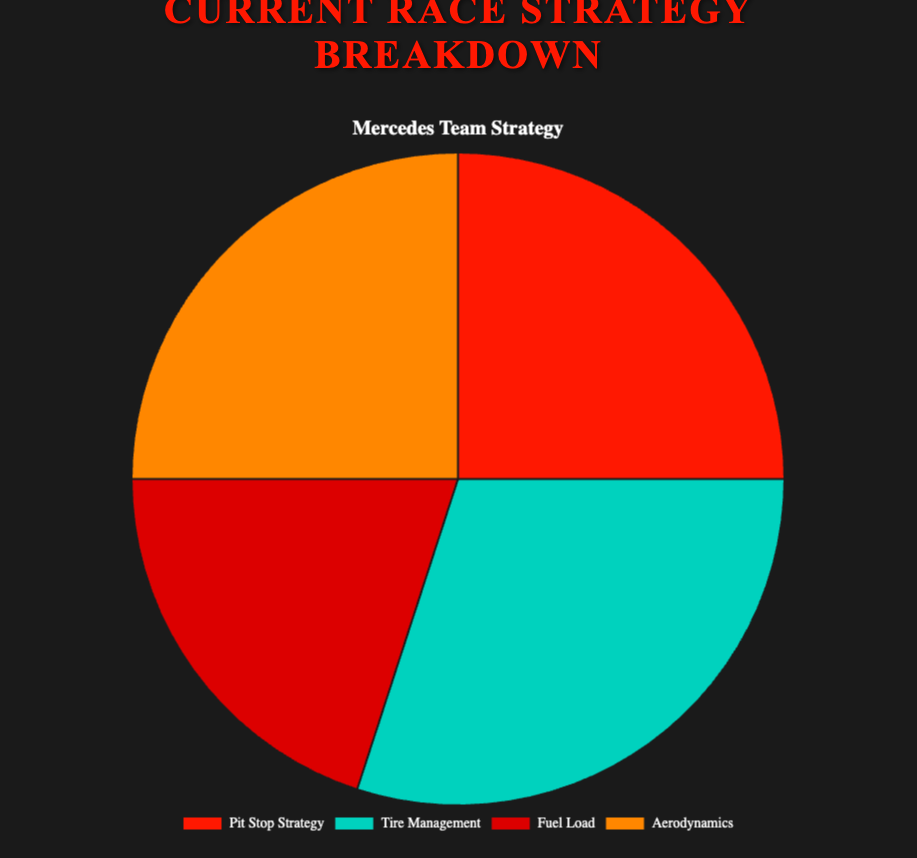How does the importance of pit stop strategy differ between Red Bull Racing and Ferrari? Red Bull Racing attributes only 20% to pit stop strategy while Ferrari attributes 30%. The difference is calculated as 30% - 20% = 10%.
Answer: 10% What is the least emphasized strategy for McLaren? By examining the breakdown for McLaren, the least emphasized strategy is Aerodynamics at 20%.
Answer: Aerodynamics Among all strategies, which one is given the most emphasis by Red Bull Racing? For Red Bull Racing, Tire Management is given the most emphasis at 35%.
Answer: Tire Management What is the total contribution percentage of Aerodynamics for both Mercedes and Ferrari combined? Mercedes has 25% and Ferrari has 20% for Aerodynamics. The combined total is 25% + 20% = 45%.
Answer: 45% Is the emphasis on Fuel Load the same for any two teams? Both Red Bull Racing and Mercedes emphasize Fuel Load equally at 20% each.
Answer: Yes Which visual attribute distinguishes the section representing 'Pit Stop Strategy'? The section representing 'Pit Stop Strategy' is colored red.
Answer: Red How do the tire management percentages compare between the team with the highest and lowest values? Red Bull Racing has the highest Tire Management percentage at 35%, while Ferrari has the lowest at 25%. The difference is 35% - 25% = 10%.
Answer: 10% What proportion of the total percentage does McLaren's Pit Stop Strategy occupy if combined with their Fuel Load? McLaren's percentages are 25% for Pit Stop Strategy and 25% for Fuel Load. Combined, they contribute 25% + 25% = 50%.
Answer: 50% Which team has the most balanced strategy, i.e., the smallest percentage variability among the four categories? Mercedes has the most balanced strategy with percentages: 25, 30, 20, 25. The variability is 30% - 20% = 10%.
Answer: Mercedes If one strategy needed to be improved across all teams, identifying the strategy with the highest average might help. What is the highest averaged strategy across all teams? To find the average of each strategy: Pit Stop Strategy: (25+20+30+25)/4 = 25%, Tire Management: (30+35+25+30)/4 = 30%, Fuel Load: (20+20+25+25)/4 = 22.5%, Aerodynamics: (25+25+20+20)/4 = 22.5%. The highest average is Tire Management at 30%.
Answer: Tire Management 